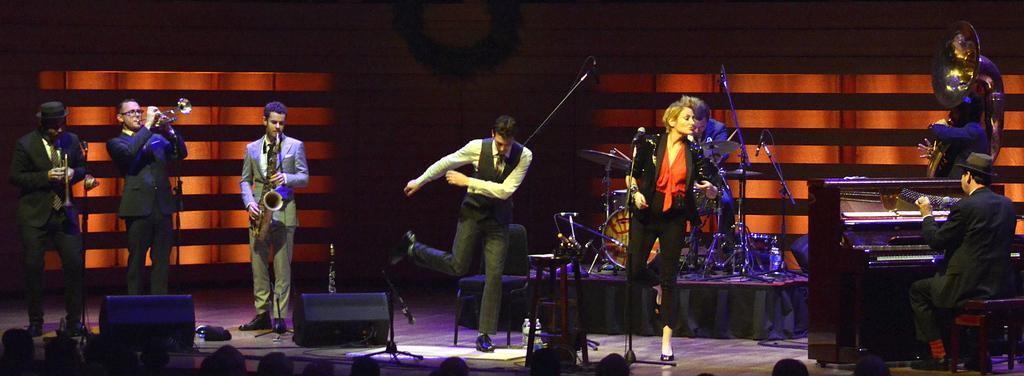Could you give a brief overview of what you see in this image? In this image we can see people standing and some of them are playing musical instruments. At the bottom there are speakers and we can see mics placed on the stands. 